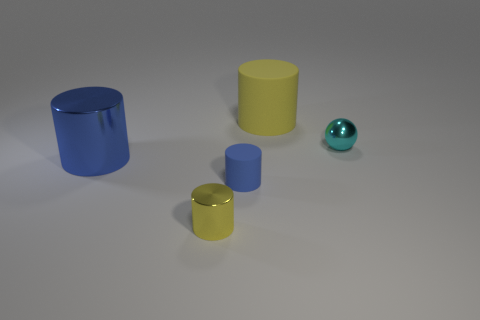Which object stands out the most due to its color? The teal sphere stands out the most as it contrasts with the other objects which have more subdued colors. 